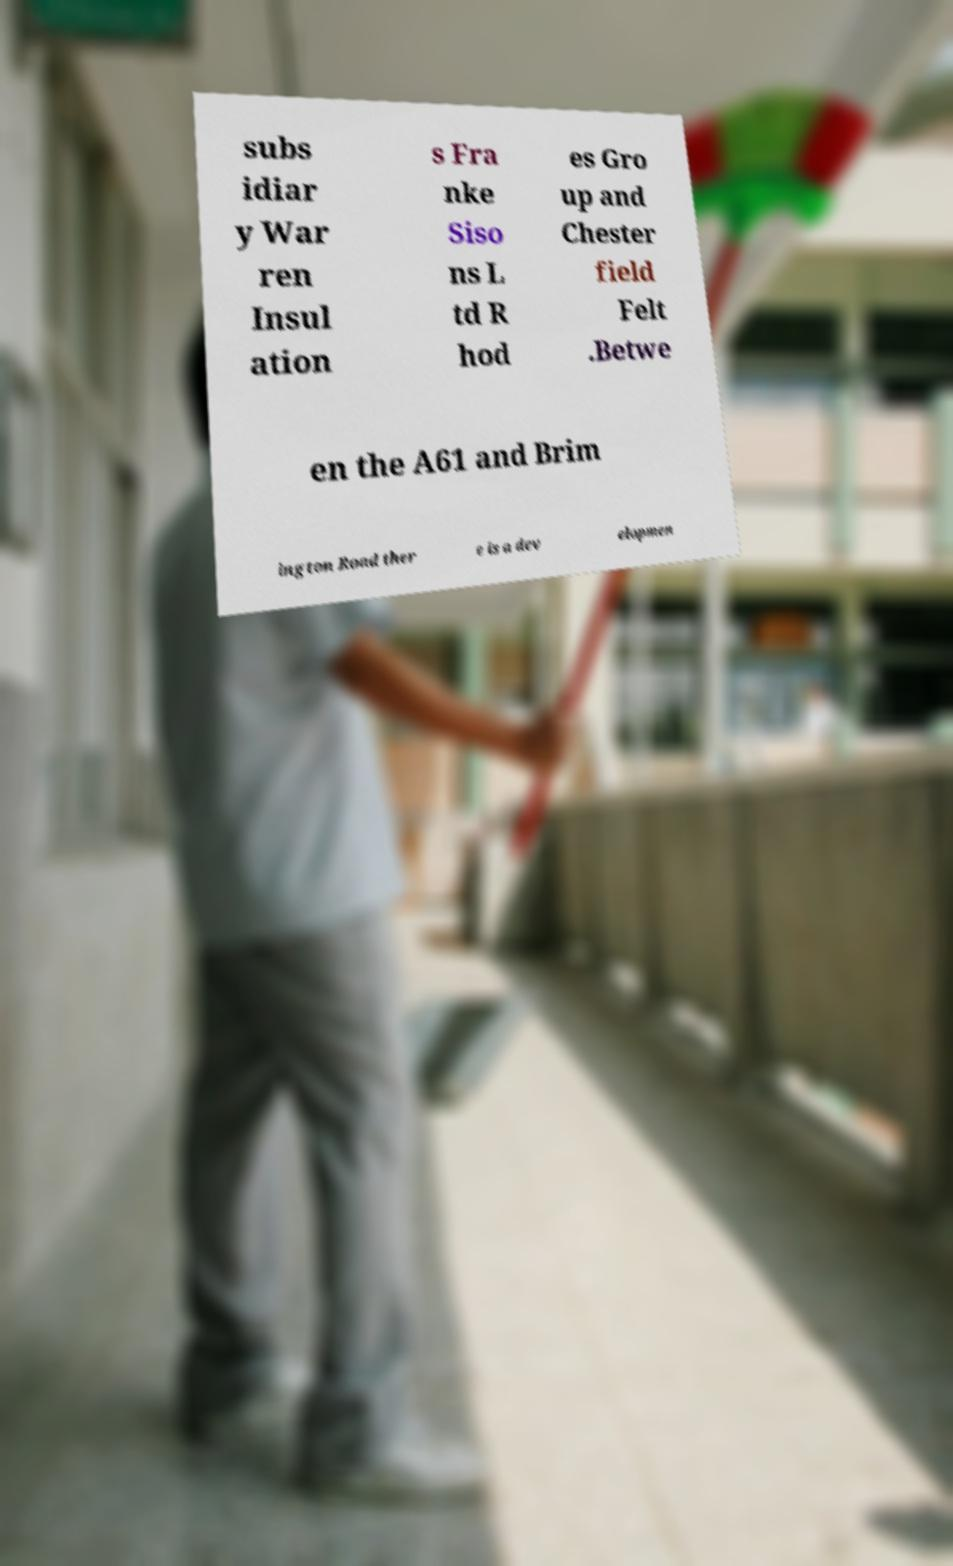What messages or text are displayed in this image? I need them in a readable, typed format. subs idiar y War ren Insul ation s Fra nke Siso ns L td R hod es Gro up and Chester field Felt .Betwe en the A61 and Brim ington Road ther e is a dev elopmen 